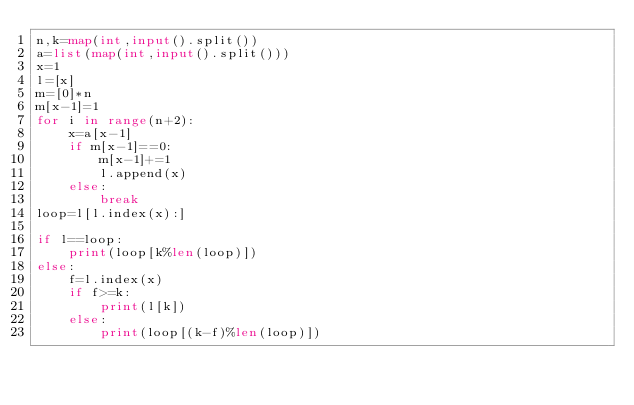<code> <loc_0><loc_0><loc_500><loc_500><_Python_>n,k=map(int,input().split())
a=list(map(int,input().split()))
x=1
l=[x]
m=[0]*n
m[x-1]=1
for i in range(n+2):
    x=a[x-1]
    if m[x-1]==0:
        m[x-1]+=1
        l.append(x)
    else:
        break
loop=l[l.index(x):]

if l==loop:
    print(loop[k%len(loop)])
else:
    f=l.index(x)
    if f>=k:
        print(l[k])
    else:
        print(loop[(k-f)%len(loop)])
</code> 